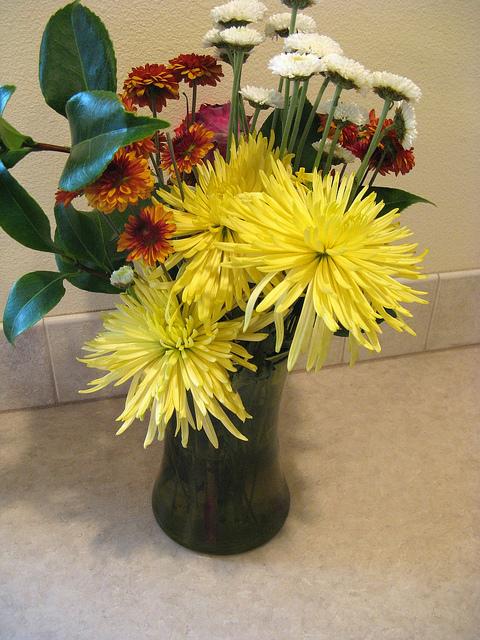Are these cut flowers?
Keep it brief. Yes. Are these flowers real or silk?
Give a very brief answer. Real. What color are the front flowers?
Keep it brief. Yellow. Who bought the flowers?
Quick response, please. Husband. 